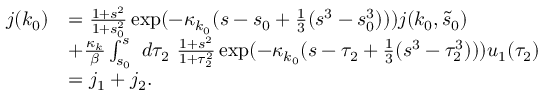<formula> <loc_0><loc_0><loc_500><loc_500>\begin{array} { r l } { j ( k _ { 0 } ) } & { = \frac { 1 + s ^ { 2 } } { 1 + s _ { 0 } ^ { 2 } } \exp ( - \kappa _ { k _ { 0 } } ( s - s _ { 0 } + \frac { 1 } { 3 } ( s ^ { 3 } - s _ { 0 } ^ { 3 } ) ) ) j ( k _ { 0 } , \tilde { s } _ { 0 } ) } \\ & { + \frac { \kappa _ { k } } \beta \int _ { s _ { 0 } } ^ { s } \ d \tau _ { 2 } \ \frac { 1 + s ^ { 2 } } { 1 + \tau _ { 2 } ^ { 2 } } \exp ( - \kappa _ { k _ { 0 } } ( s - \tau _ { 2 } + \frac { 1 } { 3 } ( s ^ { 3 } - \tau _ { 2 } ^ { 3 } ) ) ) u _ { 1 } ( \tau _ { 2 } ) } \\ & { = j _ { 1 } + j _ { 2 } . } \end{array}</formula> 